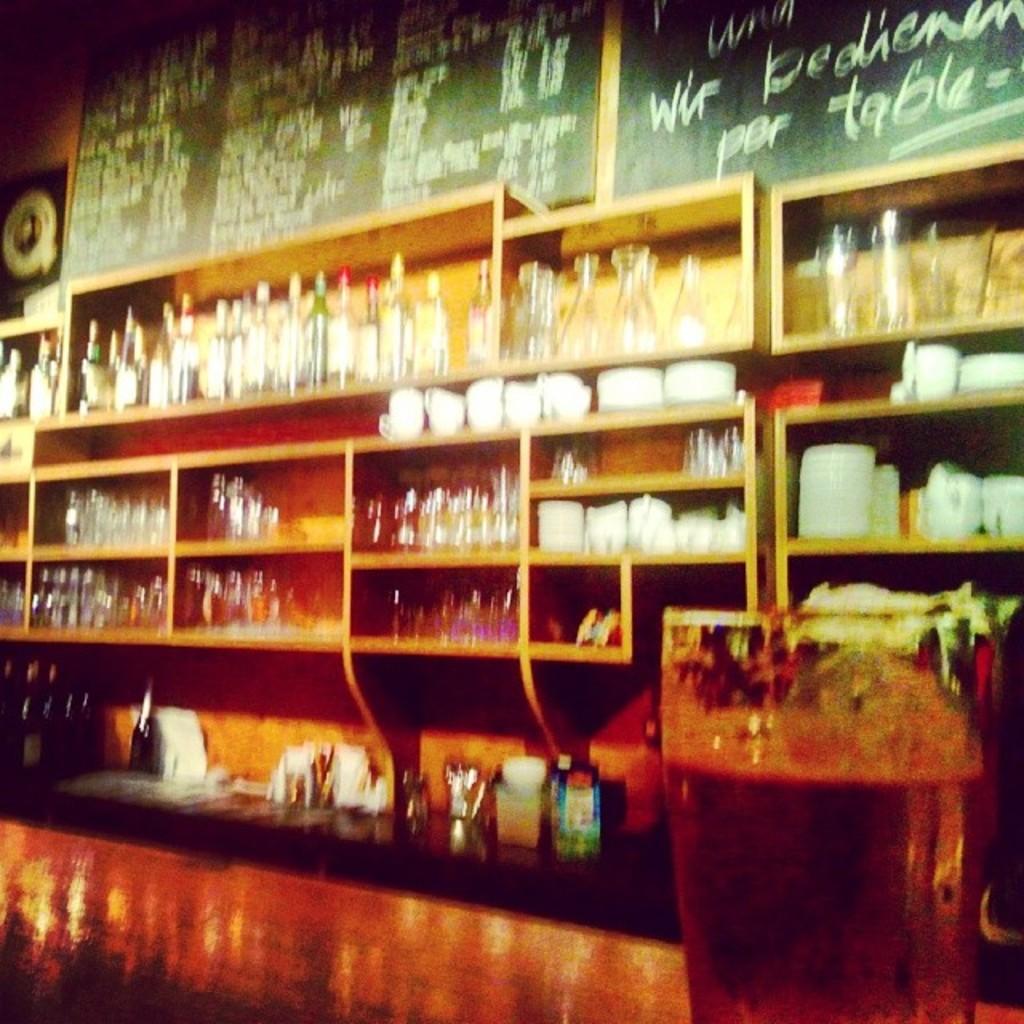This is  ketchan?
Provide a succinct answer. Answering does not require reading text in the image. 